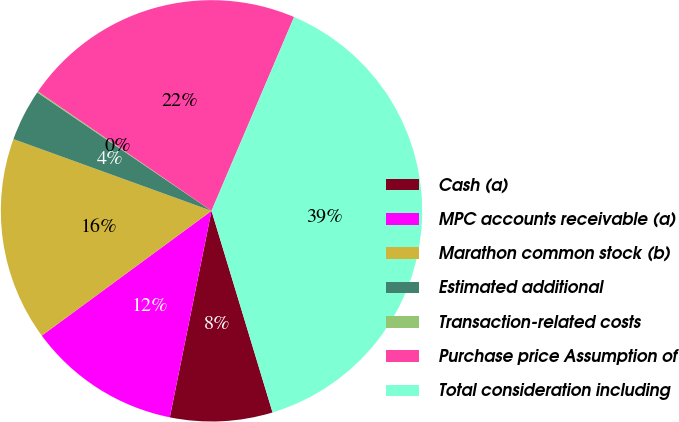Convert chart. <chart><loc_0><loc_0><loc_500><loc_500><pie_chart><fcel>Cash (a)<fcel>MPC accounts receivable (a)<fcel>Marathon common stock (b)<fcel>Estimated additional<fcel>Transaction-related costs<fcel>Purchase price Assumption of<fcel>Total consideration including<nl><fcel>7.85%<fcel>11.74%<fcel>15.62%<fcel>3.97%<fcel>0.09%<fcel>21.82%<fcel>38.91%<nl></chart> 